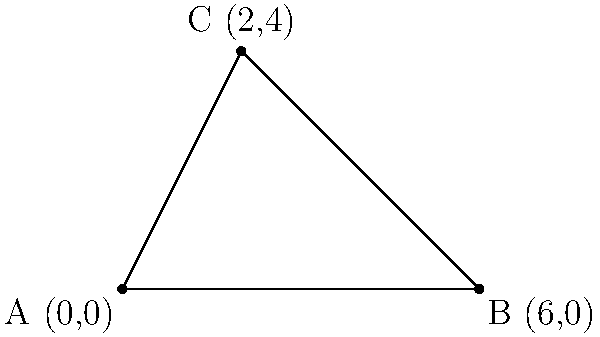As a botanist studying a monodominant forest of coniferous trees, you've identified a triangular plot for intensive research. The vertices of this plot are located at coordinates A(0,0), B(6,0), and C(2,4). Calculate the area of this triangular forest plot in square units. To calculate the area of a triangle given the coordinates of its vertices, we can use the following steps:

1. Let's recall the formula for the area of a triangle using coordinates:
   $$\text{Area} = \frac{1}{2}|x_1(y_2 - y_3) + x_2(y_3 - y_1) + x_3(y_1 - y_2)|$$

2. Identify the coordinates:
   A(x₁, y₁) = (0, 0)
   B(x₂, y₂) = (6, 0)
   C(x₃, y₃) = (2, 4)

3. Substitute these values into the formula:
   $$\text{Area} = \frac{1}{2}|0(0 - 4) + 6(4 - 0) + 2(0 - 0)|$$

4. Simplify:
   $$\text{Area} = \frac{1}{2}|0 + 24 + 0|$$
   $$\text{Area} = \frac{1}{2}|24|$$
   $$\text{Area} = \frac{1}{2}(24)$$
   $$\text{Area} = 12$$

Therefore, the area of the triangular forest plot is 12 square units.
Answer: 12 square units 